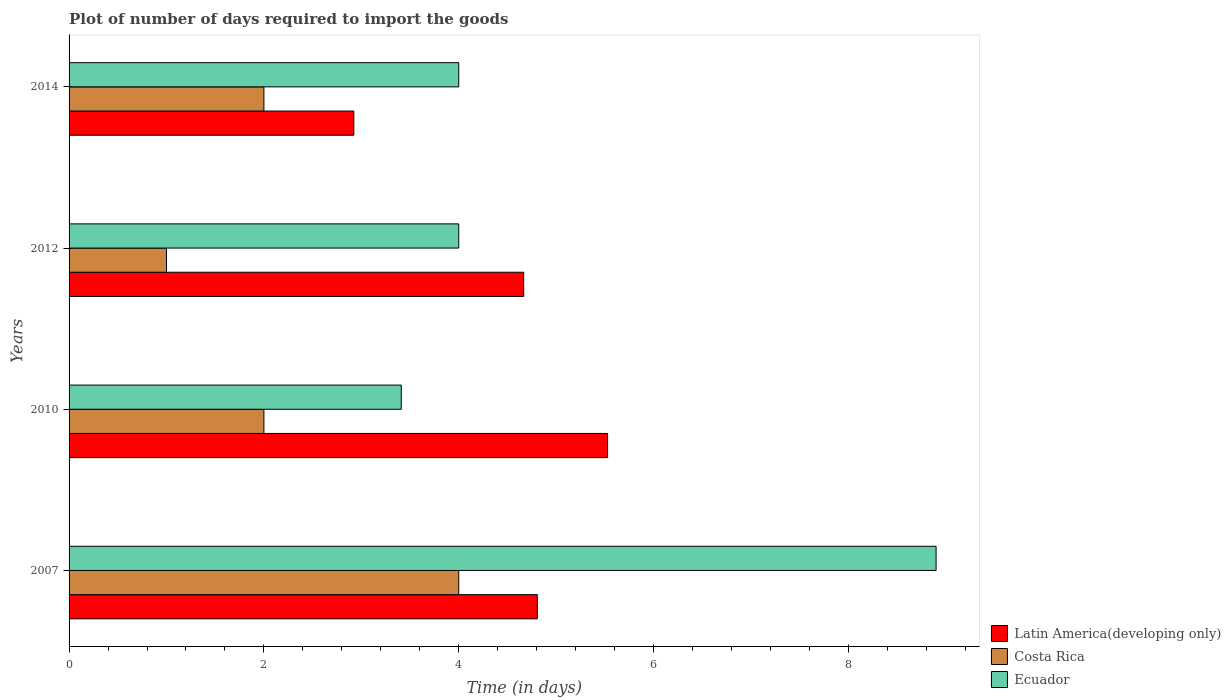How many different coloured bars are there?
Keep it short and to the point. 3. How many groups of bars are there?
Provide a succinct answer. 4. Are the number of bars per tick equal to the number of legend labels?
Your response must be concise. Yes. Are the number of bars on each tick of the Y-axis equal?
Your response must be concise. Yes. How many bars are there on the 3rd tick from the bottom?
Make the answer very short. 3. What is the label of the 1st group of bars from the top?
Give a very brief answer. 2014. In how many cases, is the number of bars for a given year not equal to the number of legend labels?
Offer a terse response. 0. What is the time required to import goods in Latin America(developing only) in 2012?
Offer a terse response. 4.67. Across all years, what is the maximum time required to import goods in Ecuador?
Offer a terse response. 8.9. Across all years, what is the minimum time required to import goods in Costa Rica?
Your response must be concise. 1. In which year was the time required to import goods in Costa Rica minimum?
Ensure brevity in your answer.  2012. What is the total time required to import goods in Costa Rica in the graph?
Keep it short and to the point. 9. What is the difference between the time required to import goods in Ecuador in 2007 and that in 2012?
Ensure brevity in your answer.  4.9. What is the difference between the time required to import goods in Ecuador in 2007 and the time required to import goods in Costa Rica in 2012?
Provide a short and direct response. 7.9. What is the average time required to import goods in Ecuador per year?
Ensure brevity in your answer.  5.08. In the year 2012, what is the difference between the time required to import goods in Latin America(developing only) and time required to import goods in Ecuador?
Give a very brief answer. 0.67. What is the ratio of the time required to import goods in Latin America(developing only) in 2012 to that in 2014?
Offer a terse response. 1.6. Is the difference between the time required to import goods in Latin America(developing only) in 2007 and 2012 greater than the difference between the time required to import goods in Ecuador in 2007 and 2012?
Give a very brief answer. No. What is the difference between the highest and the second highest time required to import goods in Ecuador?
Provide a short and direct response. 4.9. What is the difference between the highest and the lowest time required to import goods in Costa Rica?
Keep it short and to the point. 3. Is the sum of the time required to import goods in Costa Rica in 2010 and 2012 greater than the maximum time required to import goods in Ecuador across all years?
Keep it short and to the point. No. What does the 2nd bar from the top in 2010 represents?
Give a very brief answer. Costa Rica. Is it the case that in every year, the sum of the time required to import goods in Costa Rica and time required to import goods in Ecuador is greater than the time required to import goods in Latin America(developing only)?
Offer a very short reply. No. Are all the bars in the graph horizontal?
Your answer should be very brief. Yes. What is the difference between two consecutive major ticks on the X-axis?
Keep it short and to the point. 2. Are the values on the major ticks of X-axis written in scientific E-notation?
Offer a very short reply. No. Does the graph contain any zero values?
Provide a succinct answer. No. What is the title of the graph?
Provide a succinct answer. Plot of number of days required to import the goods. Does "Sub-Saharan Africa (developing only)" appear as one of the legend labels in the graph?
Your response must be concise. No. What is the label or title of the X-axis?
Ensure brevity in your answer.  Time (in days). What is the Time (in days) of Latin America(developing only) in 2007?
Ensure brevity in your answer.  4.81. What is the Time (in days) of Costa Rica in 2007?
Keep it short and to the point. 4. What is the Time (in days) of Ecuador in 2007?
Keep it short and to the point. 8.9. What is the Time (in days) in Latin America(developing only) in 2010?
Keep it short and to the point. 5.53. What is the Time (in days) in Costa Rica in 2010?
Offer a terse response. 2. What is the Time (in days) of Ecuador in 2010?
Give a very brief answer. 3.41. What is the Time (in days) in Latin America(developing only) in 2012?
Give a very brief answer. 4.67. What is the Time (in days) in Latin America(developing only) in 2014?
Keep it short and to the point. 2.92. What is the Time (in days) of Ecuador in 2014?
Your answer should be compact. 4. Across all years, what is the maximum Time (in days) of Latin America(developing only)?
Your answer should be compact. 5.53. Across all years, what is the maximum Time (in days) in Ecuador?
Your answer should be compact. 8.9. Across all years, what is the minimum Time (in days) in Latin America(developing only)?
Your answer should be compact. 2.92. Across all years, what is the minimum Time (in days) of Ecuador?
Your response must be concise. 3.41. What is the total Time (in days) of Latin America(developing only) in the graph?
Your answer should be compact. 17.92. What is the total Time (in days) in Ecuador in the graph?
Offer a terse response. 20.31. What is the difference between the Time (in days) in Latin America(developing only) in 2007 and that in 2010?
Provide a short and direct response. -0.72. What is the difference between the Time (in days) of Ecuador in 2007 and that in 2010?
Your answer should be very brief. 5.49. What is the difference between the Time (in days) in Latin America(developing only) in 2007 and that in 2012?
Provide a succinct answer. 0.14. What is the difference between the Time (in days) in Latin America(developing only) in 2007 and that in 2014?
Your response must be concise. 1.88. What is the difference between the Time (in days) of Latin America(developing only) in 2010 and that in 2012?
Your answer should be compact. 0.86. What is the difference between the Time (in days) of Costa Rica in 2010 and that in 2012?
Provide a short and direct response. 1. What is the difference between the Time (in days) in Ecuador in 2010 and that in 2012?
Give a very brief answer. -0.59. What is the difference between the Time (in days) in Latin America(developing only) in 2010 and that in 2014?
Provide a succinct answer. 2.6. What is the difference between the Time (in days) of Costa Rica in 2010 and that in 2014?
Your response must be concise. 0. What is the difference between the Time (in days) of Ecuador in 2010 and that in 2014?
Offer a very short reply. -0.59. What is the difference between the Time (in days) in Latin America(developing only) in 2012 and that in 2014?
Your response must be concise. 1.74. What is the difference between the Time (in days) of Ecuador in 2012 and that in 2014?
Offer a terse response. 0. What is the difference between the Time (in days) in Latin America(developing only) in 2007 and the Time (in days) in Costa Rica in 2010?
Make the answer very short. 2.81. What is the difference between the Time (in days) in Latin America(developing only) in 2007 and the Time (in days) in Ecuador in 2010?
Make the answer very short. 1.4. What is the difference between the Time (in days) of Costa Rica in 2007 and the Time (in days) of Ecuador in 2010?
Make the answer very short. 0.59. What is the difference between the Time (in days) of Latin America(developing only) in 2007 and the Time (in days) of Costa Rica in 2012?
Your answer should be compact. 3.81. What is the difference between the Time (in days) in Latin America(developing only) in 2007 and the Time (in days) in Ecuador in 2012?
Ensure brevity in your answer.  0.81. What is the difference between the Time (in days) in Costa Rica in 2007 and the Time (in days) in Ecuador in 2012?
Provide a short and direct response. 0. What is the difference between the Time (in days) in Latin America(developing only) in 2007 and the Time (in days) in Costa Rica in 2014?
Provide a succinct answer. 2.81. What is the difference between the Time (in days) in Latin America(developing only) in 2007 and the Time (in days) in Ecuador in 2014?
Your response must be concise. 0.81. What is the difference between the Time (in days) in Latin America(developing only) in 2010 and the Time (in days) in Costa Rica in 2012?
Your answer should be compact. 4.53. What is the difference between the Time (in days) of Latin America(developing only) in 2010 and the Time (in days) of Ecuador in 2012?
Make the answer very short. 1.53. What is the difference between the Time (in days) of Latin America(developing only) in 2010 and the Time (in days) of Costa Rica in 2014?
Make the answer very short. 3.53. What is the difference between the Time (in days) in Latin America(developing only) in 2010 and the Time (in days) in Ecuador in 2014?
Offer a very short reply. 1.53. What is the difference between the Time (in days) in Costa Rica in 2010 and the Time (in days) in Ecuador in 2014?
Your answer should be very brief. -2. What is the difference between the Time (in days) in Latin America(developing only) in 2012 and the Time (in days) in Costa Rica in 2014?
Your answer should be compact. 2.67. What is the difference between the Time (in days) of Latin America(developing only) in 2012 and the Time (in days) of Ecuador in 2014?
Ensure brevity in your answer.  0.67. What is the difference between the Time (in days) in Costa Rica in 2012 and the Time (in days) in Ecuador in 2014?
Provide a short and direct response. -3. What is the average Time (in days) of Latin America(developing only) per year?
Keep it short and to the point. 4.48. What is the average Time (in days) of Costa Rica per year?
Your answer should be compact. 2.25. What is the average Time (in days) in Ecuador per year?
Offer a terse response. 5.08. In the year 2007, what is the difference between the Time (in days) in Latin America(developing only) and Time (in days) in Costa Rica?
Your answer should be compact. 0.81. In the year 2007, what is the difference between the Time (in days) in Latin America(developing only) and Time (in days) in Ecuador?
Provide a short and direct response. -4.09. In the year 2010, what is the difference between the Time (in days) of Latin America(developing only) and Time (in days) of Costa Rica?
Your response must be concise. 3.53. In the year 2010, what is the difference between the Time (in days) of Latin America(developing only) and Time (in days) of Ecuador?
Make the answer very short. 2.12. In the year 2010, what is the difference between the Time (in days) of Costa Rica and Time (in days) of Ecuador?
Provide a succinct answer. -1.41. In the year 2012, what is the difference between the Time (in days) of Latin America(developing only) and Time (in days) of Costa Rica?
Offer a terse response. 3.67. In the year 2014, what is the difference between the Time (in days) of Latin America(developing only) and Time (in days) of Costa Rica?
Your response must be concise. 0.92. In the year 2014, what is the difference between the Time (in days) in Latin America(developing only) and Time (in days) in Ecuador?
Ensure brevity in your answer.  -1.08. In the year 2014, what is the difference between the Time (in days) in Costa Rica and Time (in days) in Ecuador?
Keep it short and to the point. -2. What is the ratio of the Time (in days) of Latin America(developing only) in 2007 to that in 2010?
Offer a terse response. 0.87. What is the ratio of the Time (in days) of Ecuador in 2007 to that in 2010?
Provide a short and direct response. 2.61. What is the ratio of the Time (in days) of Costa Rica in 2007 to that in 2012?
Your answer should be very brief. 4. What is the ratio of the Time (in days) in Ecuador in 2007 to that in 2012?
Offer a terse response. 2.23. What is the ratio of the Time (in days) of Latin America(developing only) in 2007 to that in 2014?
Keep it short and to the point. 1.64. What is the ratio of the Time (in days) in Ecuador in 2007 to that in 2014?
Offer a terse response. 2.23. What is the ratio of the Time (in days) of Latin America(developing only) in 2010 to that in 2012?
Your response must be concise. 1.18. What is the ratio of the Time (in days) in Ecuador in 2010 to that in 2012?
Provide a succinct answer. 0.85. What is the ratio of the Time (in days) in Latin America(developing only) in 2010 to that in 2014?
Ensure brevity in your answer.  1.89. What is the ratio of the Time (in days) in Costa Rica in 2010 to that in 2014?
Offer a terse response. 1. What is the ratio of the Time (in days) of Ecuador in 2010 to that in 2014?
Provide a short and direct response. 0.85. What is the ratio of the Time (in days) in Latin America(developing only) in 2012 to that in 2014?
Give a very brief answer. 1.6. What is the ratio of the Time (in days) in Ecuador in 2012 to that in 2014?
Your answer should be compact. 1. What is the difference between the highest and the second highest Time (in days) of Latin America(developing only)?
Your response must be concise. 0.72. What is the difference between the highest and the lowest Time (in days) of Latin America(developing only)?
Offer a terse response. 2.6. What is the difference between the highest and the lowest Time (in days) in Costa Rica?
Offer a terse response. 3. What is the difference between the highest and the lowest Time (in days) of Ecuador?
Your response must be concise. 5.49. 